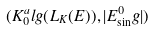<formula> <loc_0><loc_0><loc_500><loc_500>( K _ { 0 } ^ { a } l g ( L _ { K } ( E ) ) , | E ^ { 0 } _ { \sin } g | )</formula> 